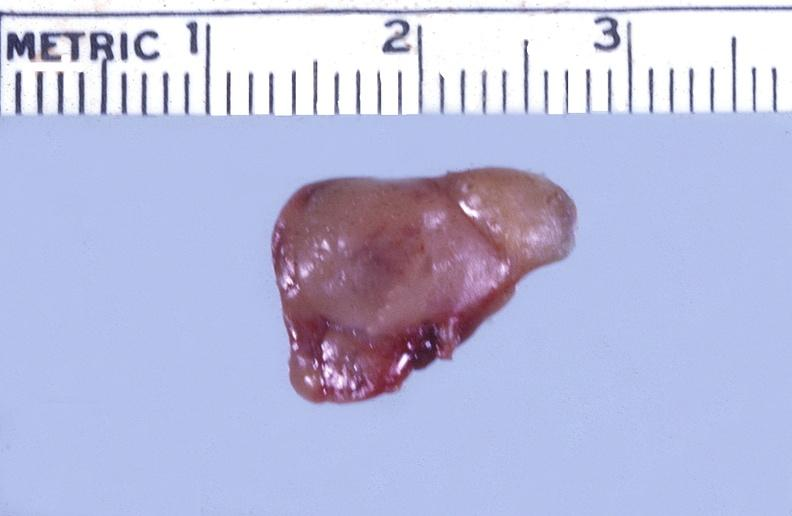s lymphangiomatosis present?
Answer the question using a single word or phrase. No 